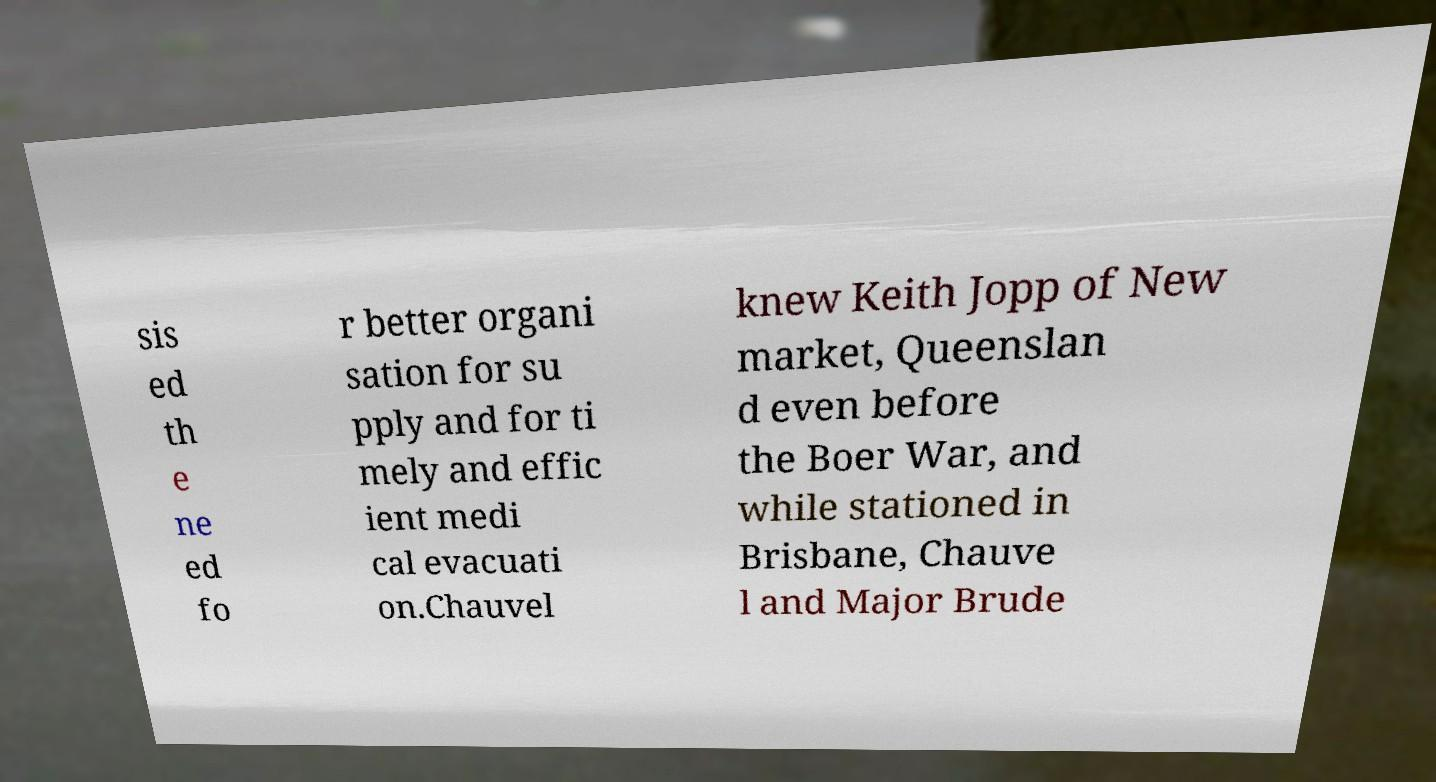I need the written content from this picture converted into text. Can you do that? sis ed th e ne ed fo r better organi sation for su pply and for ti mely and effic ient medi cal evacuati on.Chauvel knew Keith Jopp of New market, Queenslan d even before the Boer War, and while stationed in Brisbane, Chauve l and Major Brude 